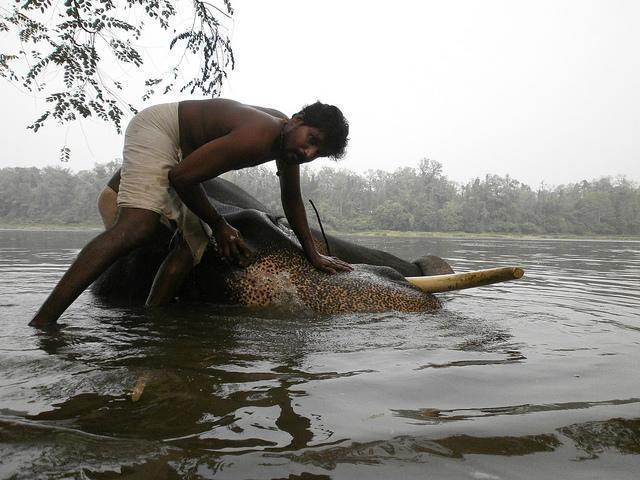What is the yellowish hard item sticking out from the animal?
Choose the correct response and explain in the format: 'Answer: answer
Rationale: rationale.'
Options: Sword, handle, tusk, beating stick. Answer: tusk.
Rationale: It's a tusk that's sort of dirty. 